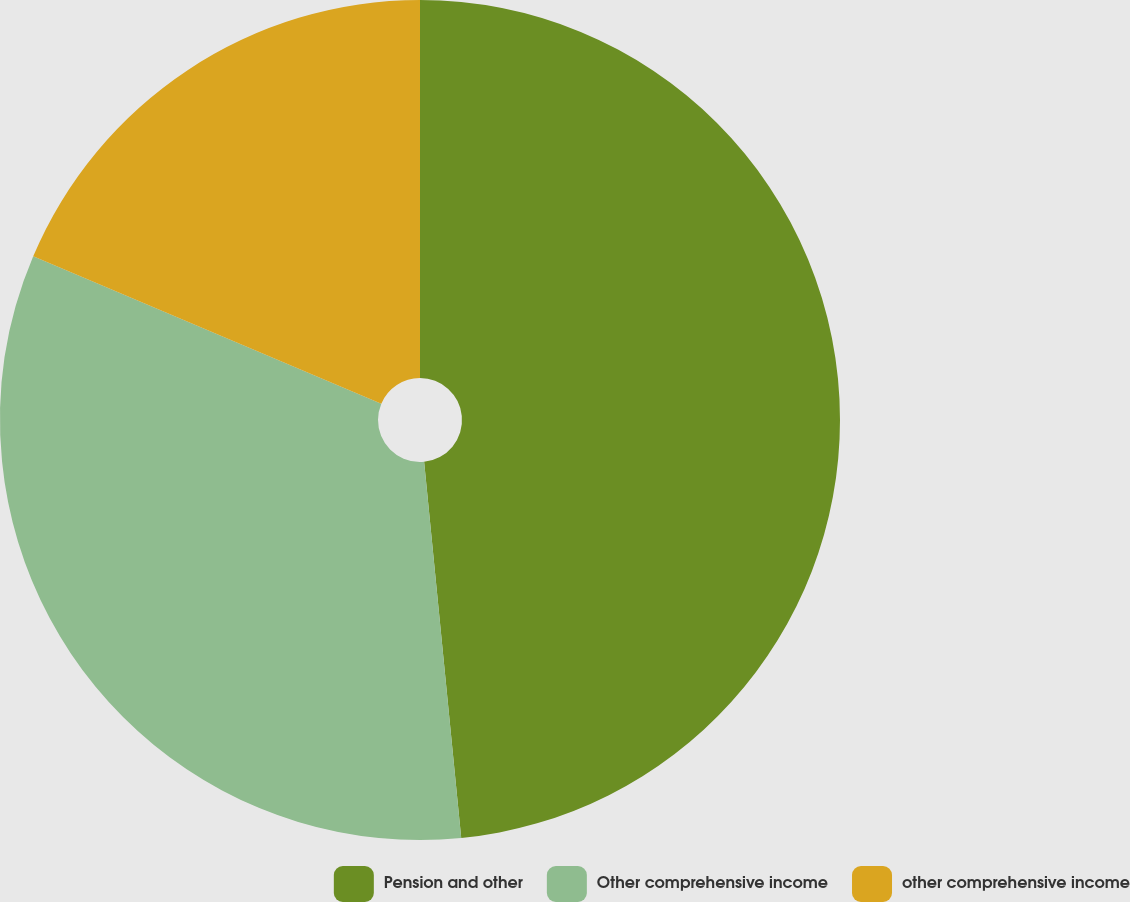<chart> <loc_0><loc_0><loc_500><loc_500><pie_chart><fcel>Pension and other<fcel>Other comprehensive income<fcel>other comprehensive income<nl><fcel>48.44%<fcel>32.94%<fcel>18.63%<nl></chart> 